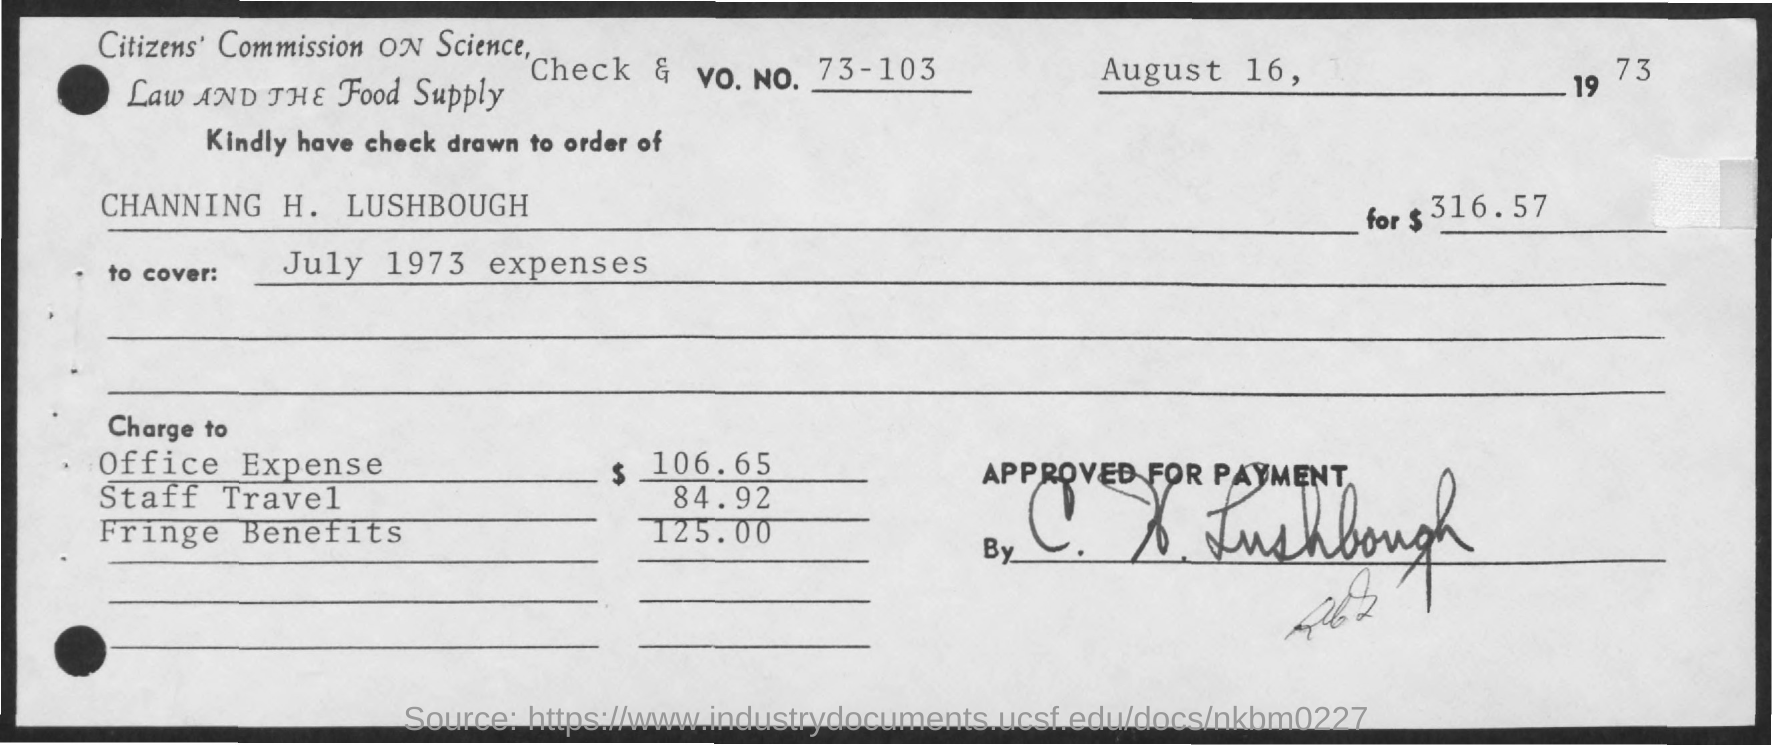Point out several critical features in this image. The amount of staff travel mentioned in the given check is 84.92... The given check lists office expenses totaling $106.65. The given check mentions the date of August 16, 1973. The given check indicates a fringe benefit amount of $125.00. Please provide the check and account number, which are 73-103. 